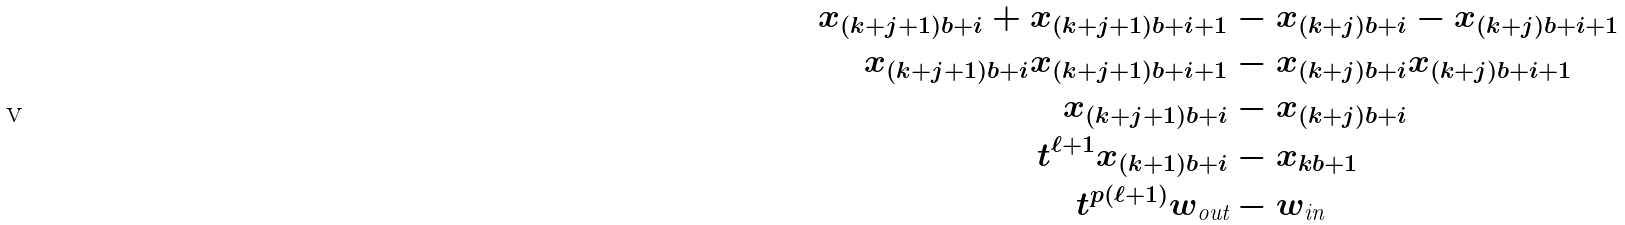<formula> <loc_0><loc_0><loc_500><loc_500>x _ { ( k + j + 1 ) b + i } + x _ { ( k + j + 1 ) b + i + 1 } & - x _ { ( k + j ) b + i } - x _ { ( k + j ) b + i + 1 } \\ x _ { ( k + j + 1 ) b + i } x _ { ( k + j + 1 ) b + i + 1 } & - x _ { ( k + j ) b + i } x _ { ( k + j ) b + i + 1 } \\ x _ { ( k + j + 1 ) b + i } & - x _ { ( k + j ) b + i } \\ t ^ { \ell + 1 } x _ { ( k + 1 ) b + i } & - x _ { k b + 1 } \\ t ^ { p ( \ell + 1 ) } w _ { \text {out} } & - w _ { \text {in} }</formula> 